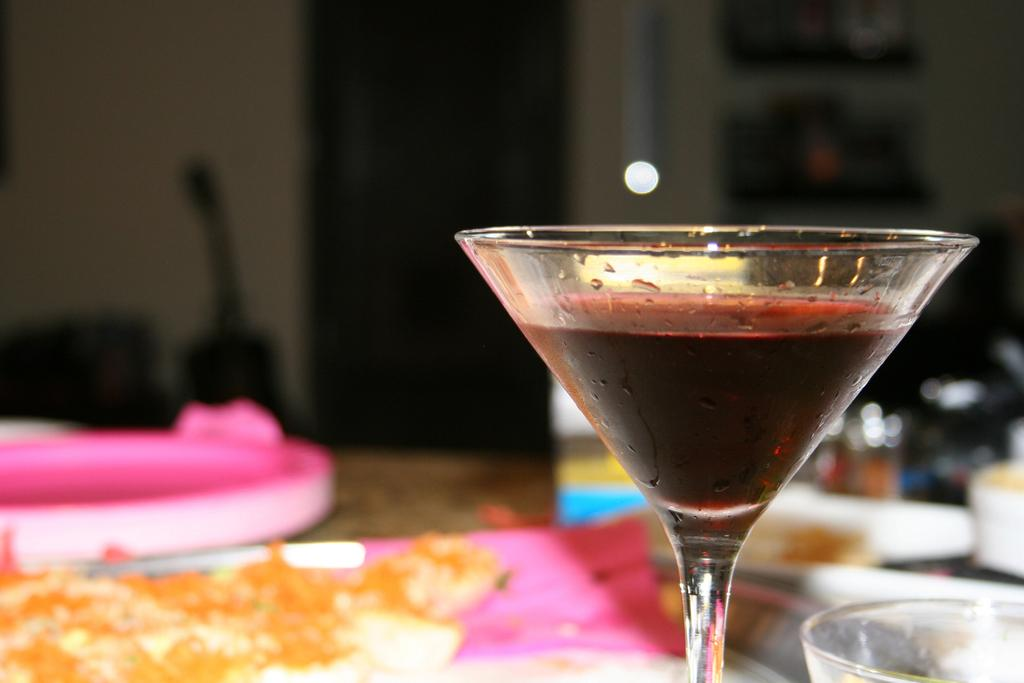What is in the glass that is visible in the image? There is a drink in the glass in the image. Where is the glass placed in the image? The glass is placed on a table in the image. What else can be seen on the table besides the glass? There is a food item on the table in the image. How many cacti are present on the table in the image? There are no cacti present on the table in the image. 